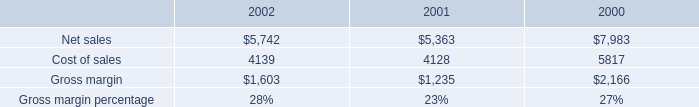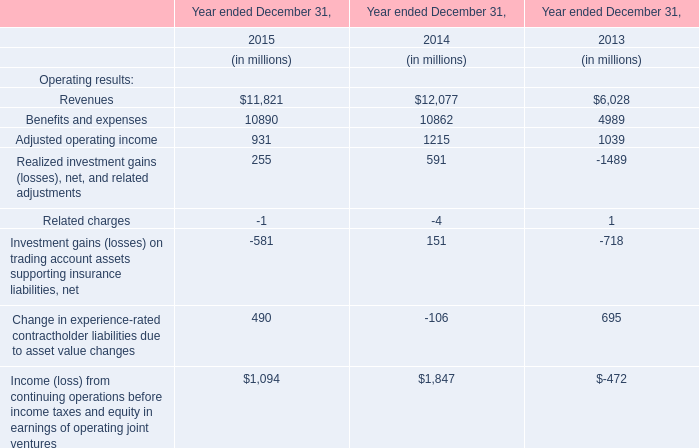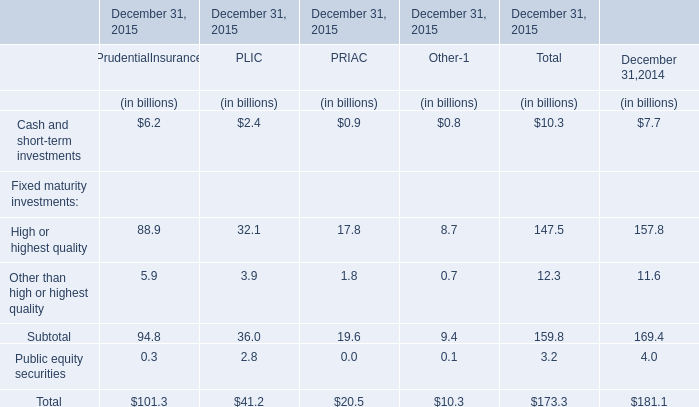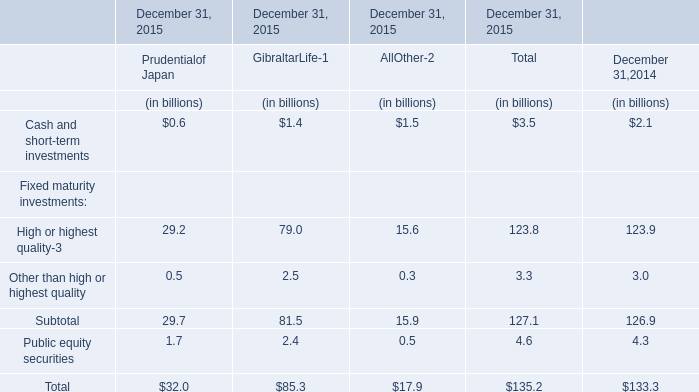what was the percentage change in net sales from 2001 to 2002? 
Computations: ((5742 - 5363) / 5363)
Answer: 0.07067. 